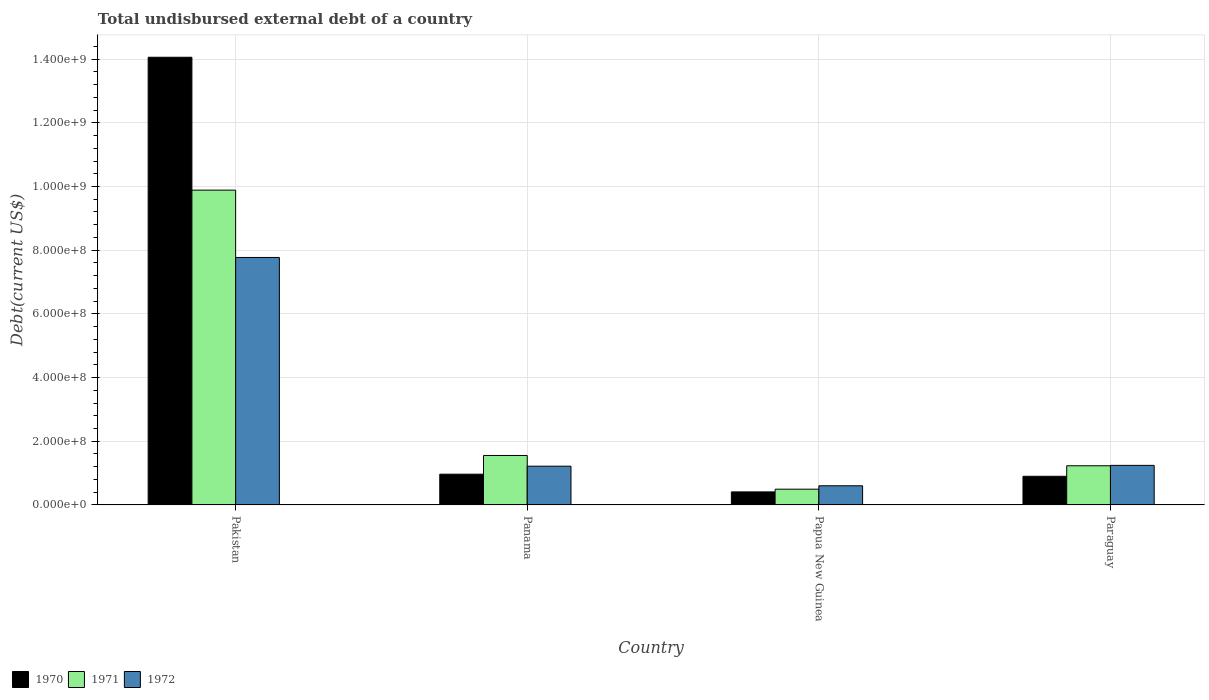How many different coloured bars are there?
Offer a very short reply. 3. How many groups of bars are there?
Your answer should be compact. 4. Are the number of bars per tick equal to the number of legend labels?
Keep it short and to the point. Yes. How many bars are there on the 2nd tick from the left?
Keep it short and to the point. 3. How many bars are there on the 2nd tick from the right?
Your response must be concise. 3. What is the label of the 1st group of bars from the left?
Your answer should be compact. Pakistan. In how many cases, is the number of bars for a given country not equal to the number of legend labels?
Your answer should be very brief. 0. What is the total undisbursed external debt in 1971 in Papua New Guinea?
Keep it short and to the point. 4.95e+07. Across all countries, what is the maximum total undisbursed external debt in 1972?
Your response must be concise. 7.77e+08. Across all countries, what is the minimum total undisbursed external debt in 1971?
Offer a terse response. 4.95e+07. In which country was the total undisbursed external debt in 1971 minimum?
Offer a very short reply. Papua New Guinea. What is the total total undisbursed external debt in 1972 in the graph?
Provide a short and direct response. 1.08e+09. What is the difference between the total undisbursed external debt in 1971 in Pakistan and that in Papua New Guinea?
Your answer should be compact. 9.39e+08. What is the difference between the total undisbursed external debt in 1971 in Panama and the total undisbursed external debt in 1970 in Pakistan?
Provide a succinct answer. -1.25e+09. What is the average total undisbursed external debt in 1972 per country?
Provide a short and direct response. 2.71e+08. What is the difference between the total undisbursed external debt of/in 1971 and total undisbursed external debt of/in 1972 in Pakistan?
Give a very brief answer. 2.11e+08. In how many countries, is the total undisbursed external debt in 1970 greater than 680000000 US$?
Your answer should be compact. 1. What is the ratio of the total undisbursed external debt in 1970 in Panama to that in Paraguay?
Offer a terse response. 1.07. What is the difference between the highest and the second highest total undisbursed external debt in 1970?
Your answer should be very brief. 1.32e+09. What is the difference between the highest and the lowest total undisbursed external debt in 1971?
Give a very brief answer. 9.39e+08. In how many countries, is the total undisbursed external debt in 1972 greater than the average total undisbursed external debt in 1972 taken over all countries?
Your response must be concise. 1. Is it the case that in every country, the sum of the total undisbursed external debt in 1970 and total undisbursed external debt in 1971 is greater than the total undisbursed external debt in 1972?
Your answer should be compact. Yes. Are all the bars in the graph horizontal?
Your answer should be compact. No. How many countries are there in the graph?
Provide a short and direct response. 4. Does the graph contain grids?
Offer a very short reply. Yes. Where does the legend appear in the graph?
Your answer should be compact. Bottom left. How many legend labels are there?
Your answer should be compact. 3. What is the title of the graph?
Your answer should be very brief. Total undisbursed external debt of a country. Does "2007" appear as one of the legend labels in the graph?
Offer a terse response. No. What is the label or title of the Y-axis?
Your response must be concise. Debt(current US$). What is the Debt(current US$) of 1970 in Pakistan?
Keep it short and to the point. 1.41e+09. What is the Debt(current US$) of 1971 in Pakistan?
Give a very brief answer. 9.89e+08. What is the Debt(current US$) of 1972 in Pakistan?
Your answer should be compact. 7.77e+08. What is the Debt(current US$) in 1970 in Panama?
Provide a succinct answer. 9.65e+07. What is the Debt(current US$) in 1971 in Panama?
Give a very brief answer. 1.55e+08. What is the Debt(current US$) of 1972 in Panama?
Your answer should be very brief. 1.22e+08. What is the Debt(current US$) of 1970 in Papua New Guinea?
Your answer should be compact. 4.09e+07. What is the Debt(current US$) in 1971 in Papua New Guinea?
Keep it short and to the point. 4.95e+07. What is the Debt(current US$) of 1972 in Papua New Guinea?
Provide a short and direct response. 6.02e+07. What is the Debt(current US$) of 1970 in Paraguay?
Keep it short and to the point. 9.00e+07. What is the Debt(current US$) in 1971 in Paraguay?
Your answer should be compact. 1.23e+08. What is the Debt(current US$) in 1972 in Paraguay?
Provide a short and direct response. 1.24e+08. Across all countries, what is the maximum Debt(current US$) in 1970?
Ensure brevity in your answer.  1.41e+09. Across all countries, what is the maximum Debt(current US$) in 1971?
Provide a succinct answer. 9.89e+08. Across all countries, what is the maximum Debt(current US$) of 1972?
Offer a terse response. 7.77e+08. Across all countries, what is the minimum Debt(current US$) in 1970?
Make the answer very short. 4.09e+07. Across all countries, what is the minimum Debt(current US$) of 1971?
Ensure brevity in your answer.  4.95e+07. Across all countries, what is the minimum Debt(current US$) in 1972?
Offer a terse response. 6.02e+07. What is the total Debt(current US$) of 1970 in the graph?
Your answer should be compact. 1.63e+09. What is the total Debt(current US$) in 1971 in the graph?
Your answer should be very brief. 1.32e+09. What is the total Debt(current US$) of 1972 in the graph?
Your answer should be very brief. 1.08e+09. What is the difference between the Debt(current US$) in 1970 in Pakistan and that in Panama?
Offer a very short reply. 1.31e+09. What is the difference between the Debt(current US$) of 1971 in Pakistan and that in Panama?
Offer a very short reply. 8.33e+08. What is the difference between the Debt(current US$) in 1972 in Pakistan and that in Panama?
Your answer should be compact. 6.56e+08. What is the difference between the Debt(current US$) of 1970 in Pakistan and that in Papua New Guinea?
Your response must be concise. 1.37e+09. What is the difference between the Debt(current US$) of 1971 in Pakistan and that in Papua New Guinea?
Offer a very short reply. 9.39e+08. What is the difference between the Debt(current US$) of 1972 in Pakistan and that in Papua New Guinea?
Provide a succinct answer. 7.17e+08. What is the difference between the Debt(current US$) of 1970 in Pakistan and that in Paraguay?
Provide a short and direct response. 1.32e+09. What is the difference between the Debt(current US$) in 1971 in Pakistan and that in Paraguay?
Your answer should be very brief. 8.66e+08. What is the difference between the Debt(current US$) in 1972 in Pakistan and that in Paraguay?
Your answer should be very brief. 6.53e+08. What is the difference between the Debt(current US$) in 1970 in Panama and that in Papua New Guinea?
Your answer should be very brief. 5.56e+07. What is the difference between the Debt(current US$) in 1971 in Panama and that in Papua New Guinea?
Your response must be concise. 1.06e+08. What is the difference between the Debt(current US$) in 1972 in Panama and that in Papua New Guinea?
Keep it short and to the point. 6.15e+07. What is the difference between the Debt(current US$) of 1970 in Panama and that in Paraguay?
Ensure brevity in your answer.  6.58e+06. What is the difference between the Debt(current US$) in 1971 in Panama and that in Paraguay?
Give a very brief answer. 3.23e+07. What is the difference between the Debt(current US$) in 1972 in Panama and that in Paraguay?
Offer a very short reply. -2.57e+06. What is the difference between the Debt(current US$) in 1970 in Papua New Guinea and that in Paraguay?
Your answer should be compact. -4.90e+07. What is the difference between the Debt(current US$) in 1971 in Papua New Guinea and that in Paraguay?
Offer a terse response. -7.35e+07. What is the difference between the Debt(current US$) in 1972 in Papua New Guinea and that in Paraguay?
Your response must be concise. -6.41e+07. What is the difference between the Debt(current US$) in 1970 in Pakistan and the Debt(current US$) in 1971 in Panama?
Your answer should be compact. 1.25e+09. What is the difference between the Debt(current US$) in 1970 in Pakistan and the Debt(current US$) in 1972 in Panama?
Your answer should be very brief. 1.28e+09. What is the difference between the Debt(current US$) in 1971 in Pakistan and the Debt(current US$) in 1972 in Panama?
Ensure brevity in your answer.  8.67e+08. What is the difference between the Debt(current US$) in 1970 in Pakistan and the Debt(current US$) in 1971 in Papua New Guinea?
Provide a short and direct response. 1.36e+09. What is the difference between the Debt(current US$) in 1970 in Pakistan and the Debt(current US$) in 1972 in Papua New Guinea?
Give a very brief answer. 1.35e+09. What is the difference between the Debt(current US$) of 1971 in Pakistan and the Debt(current US$) of 1972 in Papua New Guinea?
Your answer should be very brief. 9.28e+08. What is the difference between the Debt(current US$) of 1970 in Pakistan and the Debt(current US$) of 1971 in Paraguay?
Offer a terse response. 1.28e+09. What is the difference between the Debt(current US$) of 1970 in Pakistan and the Debt(current US$) of 1972 in Paraguay?
Your response must be concise. 1.28e+09. What is the difference between the Debt(current US$) of 1971 in Pakistan and the Debt(current US$) of 1972 in Paraguay?
Offer a very short reply. 8.64e+08. What is the difference between the Debt(current US$) of 1970 in Panama and the Debt(current US$) of 1971 in Papua New Guinea?
Your answer should be compact. 4.70e+07. What is the difference between the Debt(current US$) in 1970 in Panama and the Debt(current US$) in 1972 in Papua New Guinea?
Provide a short and direct response. 3.64e+07. What is the difference between the Debt(current US$) of 1971 in Panama and the Debt(current US$) of 1972 in Papua New Guinea?
Give a very brief answer. 9.52e+07. What is the difference between the Debt(current US$) in 1970 in Panama and the Debt(current US$) in 1971 in Paraguay?
Offer a very short reply. -2.65e+07. What is the difference between the Debt(current US$) in 1970 in Panama and the Debt(current US$) in 1972 in Paraguay?
Offer a terse response. -2.77e+07. What is the difference between the Debt(current US$) of 1971 in Panama and the Debt(current US$) of 1972 in Paraguay?
Provide a succinct answer. 3.11e+07. What is the difference between the Debt(current US$) of 1970 in Papua New Guinea and the Debt(current US$) of 1971 in Paraguay?
Offer a terse response. -8.21e+07. What is the difference between the Debt(current US$) of 1970 in Papua New Guinea and the Debt(current US$) of 1972 in Paraguay?
Keep it short and to the point. -8.33e+07. What is the difference between the Debt(current US$) in 1971 in Papua New Guinea and the Debt(current US$) in 1972 in Paraguay?
Your answer should be very brief. -7.48e+07. What is the average Debt(current US$) of 1970 per country?
Ensure brevity in your answer.  4.08e+08. What is the average Debt(current US$) in 1971 per country?
Provide a short and direct response. 3.29e+08. What is the average Debt(current US$) in 1972 per country?
Offer a terse response. 2.71e+08. What is the difference between the Debt(current US$) of 1970 and Debt(current US$) of 1971 in Pakistan?
Offer a terse response. 4.17e+08. What is the difference between the Debt(current US$) of 1970 and Debt(current US$) of 1972 in Pakistan?
Provide a short and direct response. 6.29e+08. What is the difference between the Debt(current US$) in 1971 and Debt(current US$) in 1972 in Pakistan?
Give a very brief answer. 2.11e+08. What is the difference between the Debt(current US$) of 1970 and Debt(current US$) of 1971 in Panama?
Give a very brief answer. -5.88e+07. What is the difference between the Debt(current US$) of 1970 and Debt(current US$) of 1972 in Panama?
Keep it short and to the point. -2.51e+07. What is the difference between the Debt(current US$) of 1971 and Debt(current US$) of 1972 in Panama?
Offer a terse response. 3.37e+07. What is the difference between the Debt(current US$) of 1970 and Debt(current US$) of 1971 in Papua New Guinea?
Provide a succinct answer. -8.56e+06. What is the difference between the Debt(current US$) in 1970 and Debt(current US$) in 1972 in Papua New Guinea?
Provide a succinct answer. -1.93e+07. What is the difference between the Debt(current US$) in 1971 and Debt(current US$) in 1972 in Papua New Guinea?
Give a very brief answer. -1.07e+07. What is the difference between the Debt(current US$) of 1970 and Debt(current US$) of 1971 in Paraguay?
Offer a very short reply. -3.31e+07. What is the difference between the Debt(current US$) in 1970 and Debt(current US$) in 1972 in Paraguay?
Keep it short and to the point. -3.43e+07. What is the difference between the Debt(current US$) in 1971 and Debt(current US$) in 1972 in Paraguay?
Your response must be concise. -1.22e+06. What is the ratio of the Debt(current US$) of 1970 in Pakistan to that in Panama?
Provide a succinct answer. 14.56. What is the ratio of the Debt(current US$) of 1971 in Pakistan to that in Panama?
Your answer should be very brief. 6.36. What is the ratio of the Debt(current US$) of 1972 in Pakistan to that in Panama?
Offer a terse response. 6.39. What is the ratio of the Debt(current US$) in 1970 in Pakistan to that in Papua New Guinea?
Offer a terse response. 34.35. What is the ratio of the Debt(current US$) of 1971 in Pakistan to that in Papua New Guinea?
Offer a terse response. 19.98. What is the ratio of the Debt(current US$) of 1972 in Pakistan to that in Papua New Guinea?
Give a very brief answer. 12.91. What is the ratio of the Debt(current US$) of 1970 in Pakistan to that in Paraguay?
Provide a short and direct response. 15.63. What is the ratio of the Debt(current US$) of 1971 in Pakistan to that in Paraguay?
Offer a terse response. 8.04. What is the ratio of the Debt(current US$) in 1972 in Pakistan to that in Paraguay?
Ensure brevity in your answer.  6.26. What is the ratio of the Debt(current US$) in 1970 in Panama to that in Papua New Guinea?
Provide a succinct answer. 2.36. What is the ratio of the Debt(current US$) of 1971 in Panama to that in Papua New Guinea?
Provide a short and direct response. 3.14. What is the ratio of the Debt(current US$) in 1972 in Panama to that in Papua New Guinea?
Give a very brief answer. 2.02. What is the ratio of the Debt(current US$) of 1970 in Panama to that in Paraguay?
Provide a short and direct response. 1.07. What is the ratio of the Debt(current US$) in 1971 in Panama to that in Paraguay?
Ensure brevity in your answer.  1.26. What is the ratio of the Debt(current US$) of 1972 in Panama to that in Paraguay?
Provide a succinct answer. 0.98. What is the ratio of the Debt(current US$) in 1970 in Papua New Guinea to that in Paraguay?
Your answer should be very brief. 0.46. What is the ratio of the Debt(current US$) in 1971 in Papua New Guinea to that in Paraguay?
Provide a succinct answer. 0.4. What is the ratio of the Debt(current US$) of 1972 in Papua New Guinea to that in Paraguay?
Your answer should be very brief. 0.48. What is the difference between the highest and the second highest Debt(current US$) in 1970?
Make the answer very short. 1.31e+09. What is the difference between the highest and the second highest Debt(current US$) of 1971?
Give a very brief answer. 8.33e+08. What is the difference between the highest and the second highest Debt(current US$) of 1972?
Give a very brief answer. 6.53e+08. What is the difference between the highest and the lowest Debt(current US$) in 1970?
Offer a terse response. 1.37e+09. What is the difference between the highest and the lowest Debt(current US$) of 1971?
Provide a short and direct response. 9.39e+08. What is the difference between the highest and the lowest Debt(current US$) of 1972?
Ensure brevity in your answer.  7.17e+08. 